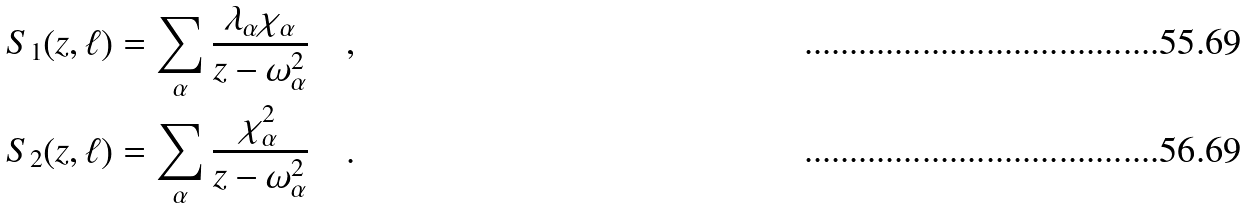Convert formula to latex. <formula><loc_0><loc_0><loc_500><loc_500>S _ { 1 } ( z , \ell ) & = \sum _ { \alpha } \frac { \lambda _ { \alpha } \chi _ { \alpha } } { z - \omega _ { \alpha } ^ { 2 } } \quad , \quad \\ S _ { 2 } ( z , \ell ) & = \sum _ { \alpha } \frac { \chi _ { \alpha } ^ { 2 } } { z - \omega _ { \alpha } ^ { 2 } } \quad .</formula> 